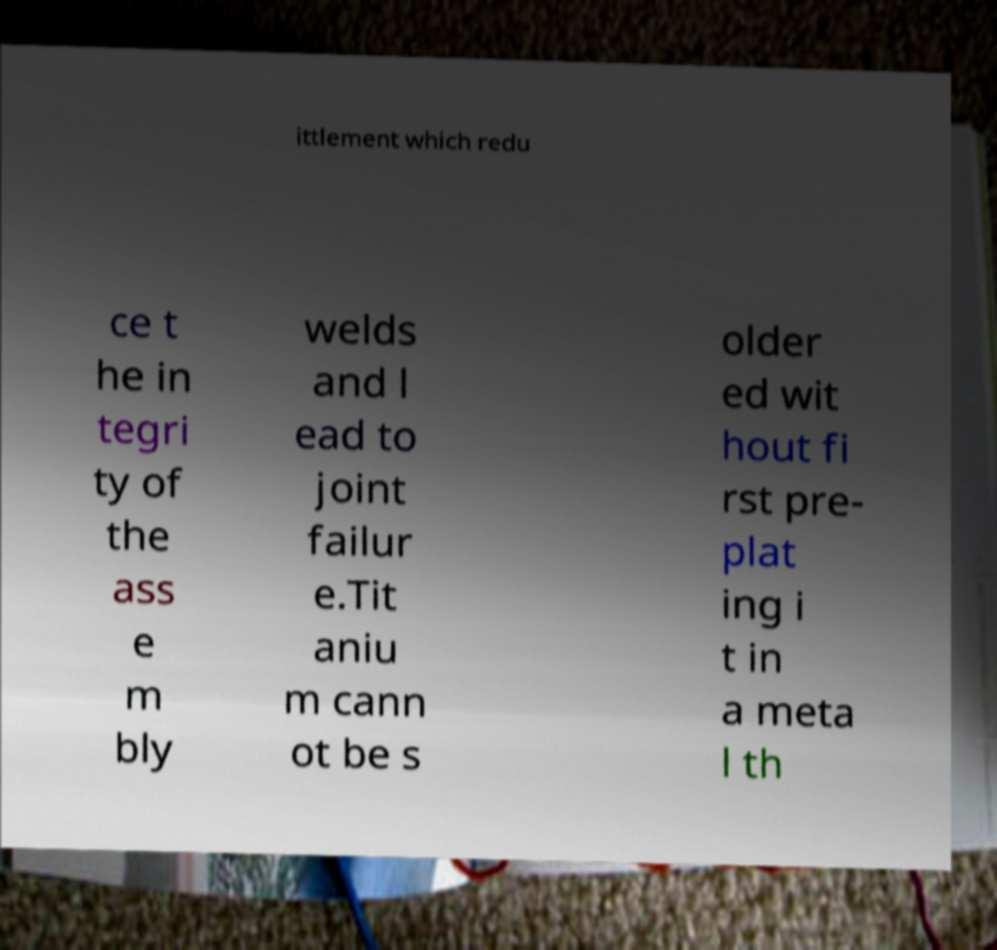What messages or text are displayed in this image? I need them in a readable, typed format. ittlement which redu ce t he in tegri ty of the ass e m bly welds and l ead to joint failur e.Tit aniu m cann ot be s older ed wit hout fi rst pre- plat ing i t in a meta l th 